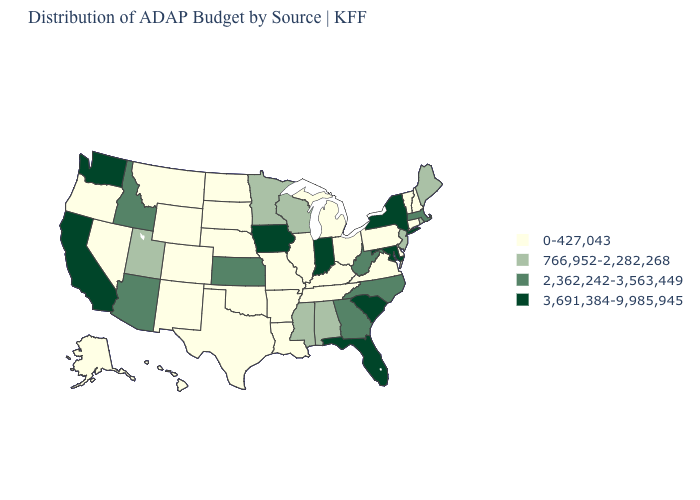What is the value of Tennessee?
Short answer required. 0-427,043. Name the states that have a value in the range 766,952-2,282,268?
Quick response, please. Alabama, Maine, Minnesota, Mississippi, New Jersey, Rhode Island, Utah, Wisconsin. What is the value of Mississippi?
Write a very short answer. 766,952-2,282,268. Among the states that border New Jersey , does Delaware have the highest value?
Quick response, please. No. Does Virginia have a lower value than Connecticut?
Write a very short answer. No. What is the lowest value in states that border North Dakota?
Answer briefly. 0-427,043. Name the states that have a value in the range 0-427,043?
Concise answer only. Alaska, Arkansas, Colorado, Connecticut, Delaware, Hawaii, Illinois, Kentucky, Louisiana, Michigan, Missouri, Montana, Nebraska, Nevada, New Hampshire, New Mexico, North Dakota, Ohio, Oklahoma, Oregon, Pennsylvania, South Dakota, Tennessee, Texas, Vermont, Virginia, Wyoming. What is the value of Mississippi?
Concise answer only. 766,952-2,282,268. Does California have the lowest value in the USA?
Write a very short answer. No. What is the value of Nebraska?
Be succinct. 0-427,043. What is the lowest value in states that border Iowa?
Short answer required. 0-427,043. Which states have the highest value in the USA?
Write a very short answer. California, Florida, Indiana, Iowa, Maryland, New York, South Carolina, Washington. Name the states that have a value in the range 2,362,242-3,563,449?
Keep it brief. Arizona, Georgia, Idaho, Kansas, Massachusetts, North Carolina, West Virginia. Among the states that border Oklahoma , does Texas have the highest value?
Short answer required. No. Among the states that border North Carolina , which have the highest value?
Short answer required. South Carolina. 